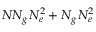<formula> <loc_0><loc_0><loc_500><loc_500>N N _ { g } N _ { e } ^ { 2 } + N _ { g } N _ { e } ^ { 2 }</formula> 